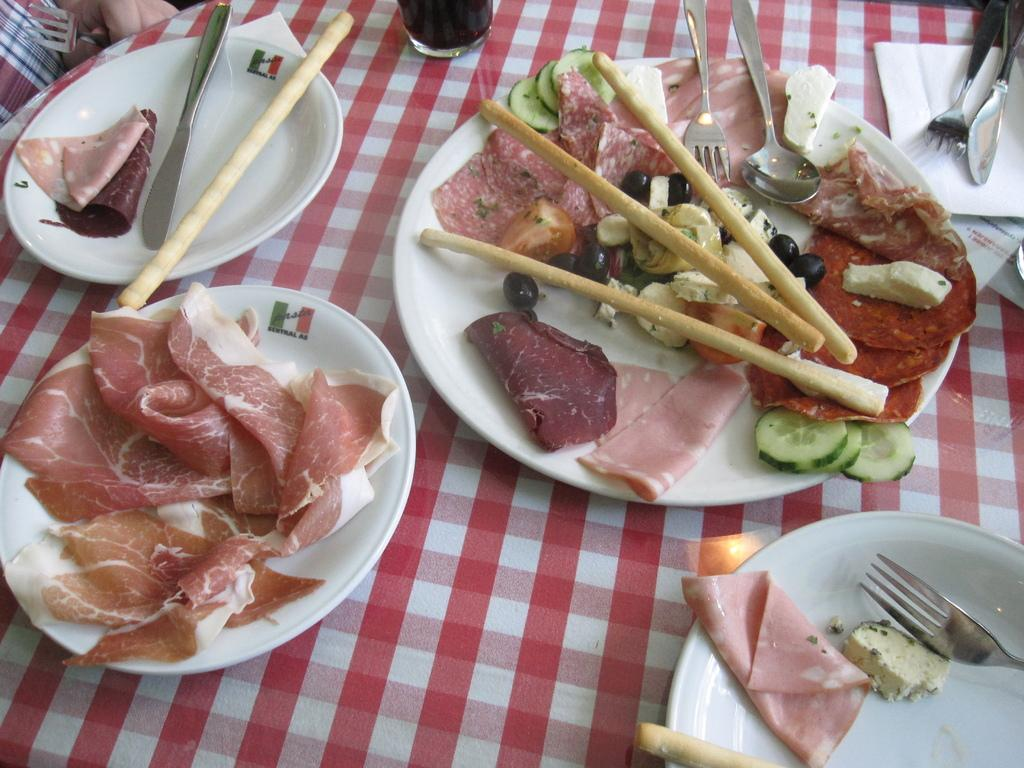What objects are on the table in the image? There are plates on a table in the image. What is on the plates? There is food on the plates. What utensils are visible in the image? A fork, a spoon, and a butter knife are visible in the image. What type of container is present in the image? There is a glass in the image. What type of profit can be seen in the image? There is no mention of profit in the image; it features plates with food, utensils, and a glass. How many birds are visible in the image? There are no birds present in the image. 